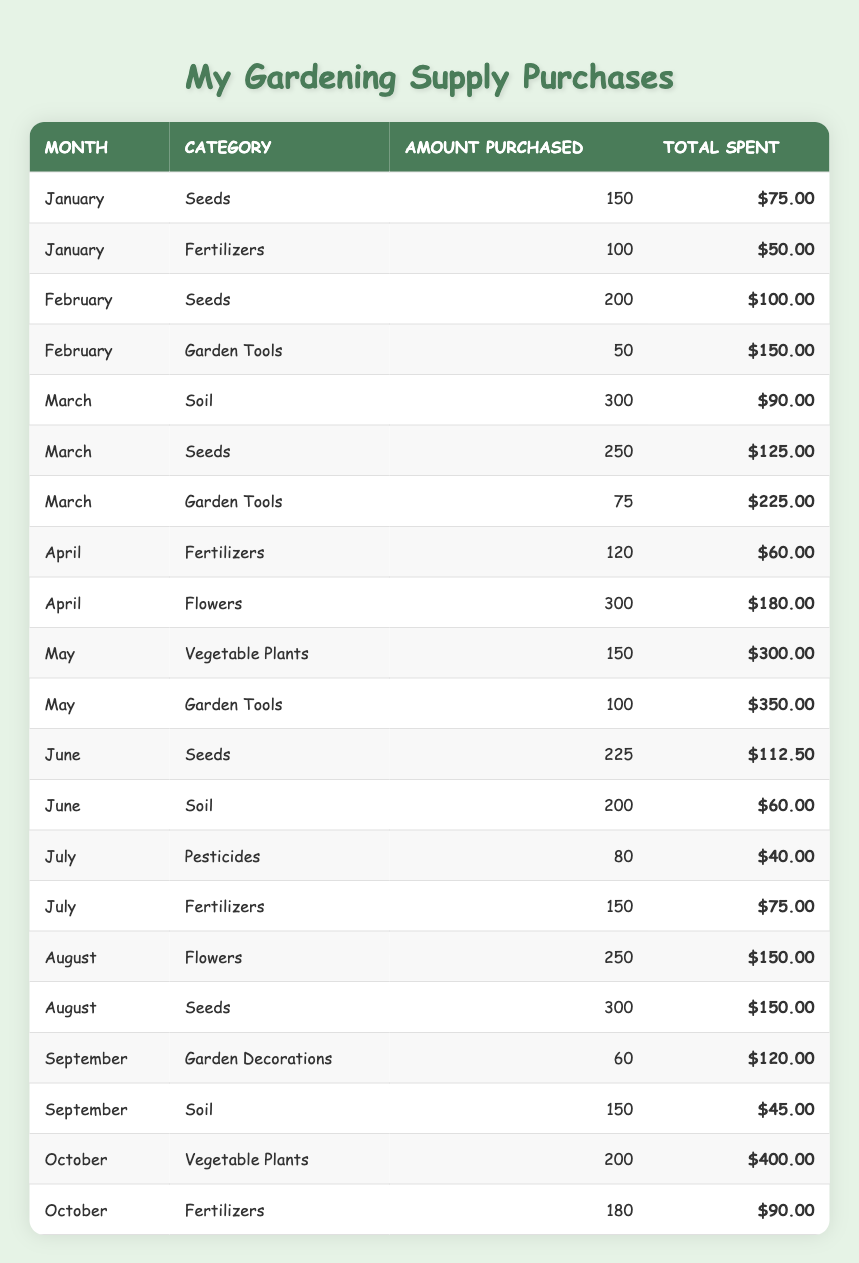What is the total amount spent on Seeds in January? In January, the table shows that 150 Seeds were purchased for a total of $75.00. Therefore, the total amount spent on Seeds in that month is simply the value provided in the table.
Answer: $75.00 How many Garden Tools were purchased in March? The table indicates that 75 Garden Tools were purchased in March. This information is directly available in the relevant row of the table.
Answer: 75 What is the total quantity of Fertilizers purchased from January to April? To find the total quantity of Fertilizers purchased from January to April, I will add the amounts from each respective month. In January, 100 were purchased, in February there were none listed, in March again none, and in April 120 were bought. This gives a total of 100 + 0 + 0 + 120 = 220.
Answer: 220 Did more Soil get purchased in July than in June? In July, the table does not list any purchases for Soil. In June, 200 Soil was purchased. Therefore, since 0 is less than 200, the answer is no.
Answer: No What was the average amount spent on Flowers across the months they were purchased? Flowers were purchased in April (300 for $180.00) and August (250 for $150.00). To find the average, we first calculate the total spent: $180 + $150 = $330. Then, we count the number of months: 2. The average is then $330 / 2 = $165.00.
Answer: $165.00 How much more was spent on Garden Tools in May compared to February? In May, the amount spent on Garden Tools was $350.00, while in February it was $150.00. To find the difference, we calculate $350 - $150 = $200.00.
Answer: $200.00 Which month had the highest amount spent on Vegetable Plants? Looking through the table, October shows an amount spent on Vegetable Plants of $400.00, which is higher than the amount spent in May (spending of $300.00). Therefore, October has the highest amount spent on Vegetable Plants.
Answer: October What is the total amount spent on Fertilizers in July? In July, the amount spent on Fertilizers is $75.00 as indicated in the table. This value is directly available for reference.
Answer: $75.00 Which month had the highest total spent on gardening supplies? We need to check each month’s total spending: January ($125.00), February ($250.00), March ($240.00), April ($240.00), May ($650.00), June ($172.50), July ($115.00), August ($300.00), September ($165.00), and October ($490.00). The highest total spent is in May, with a total of $650.00.
Answer: May 